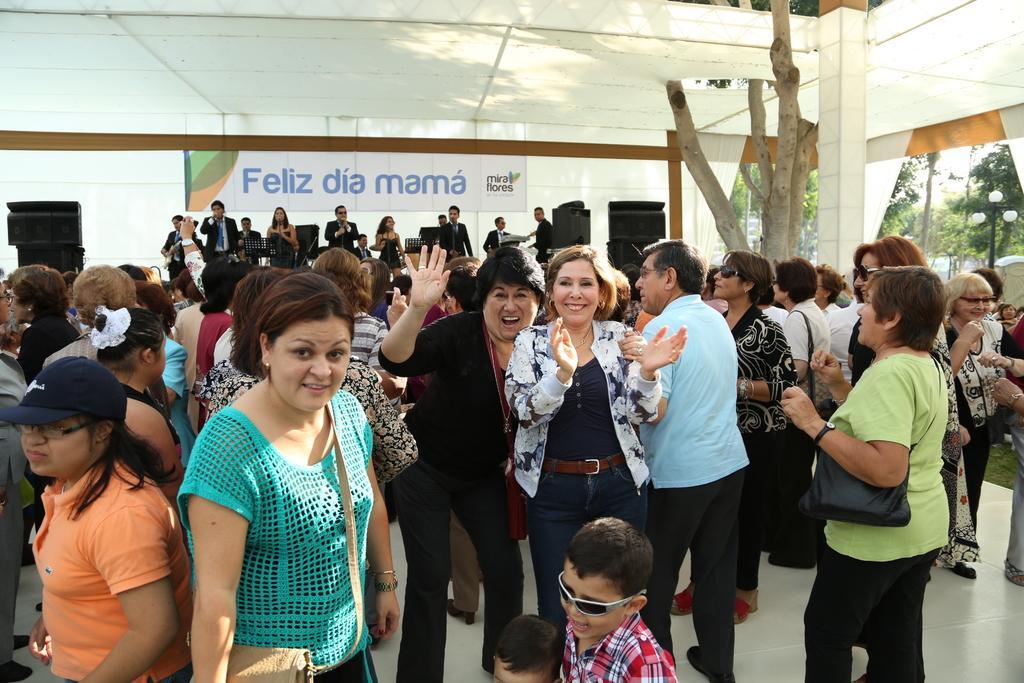Describe this image in one or two sentences. In the image there are many people standing all over the place and in the back there are few people singing and playing musical instruments on the stage with a banner behind them, there are trees on the right side. 